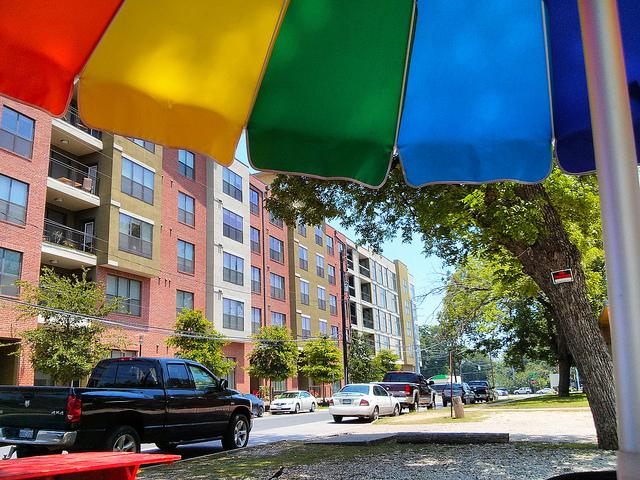Is this umbrella multi colored?
Answer briefly. Yes. Are the trees on the left naturally occurring?
Answer briefly. No. Was the photographer in the shade when they took this photo?
Short answer required. Yes. 